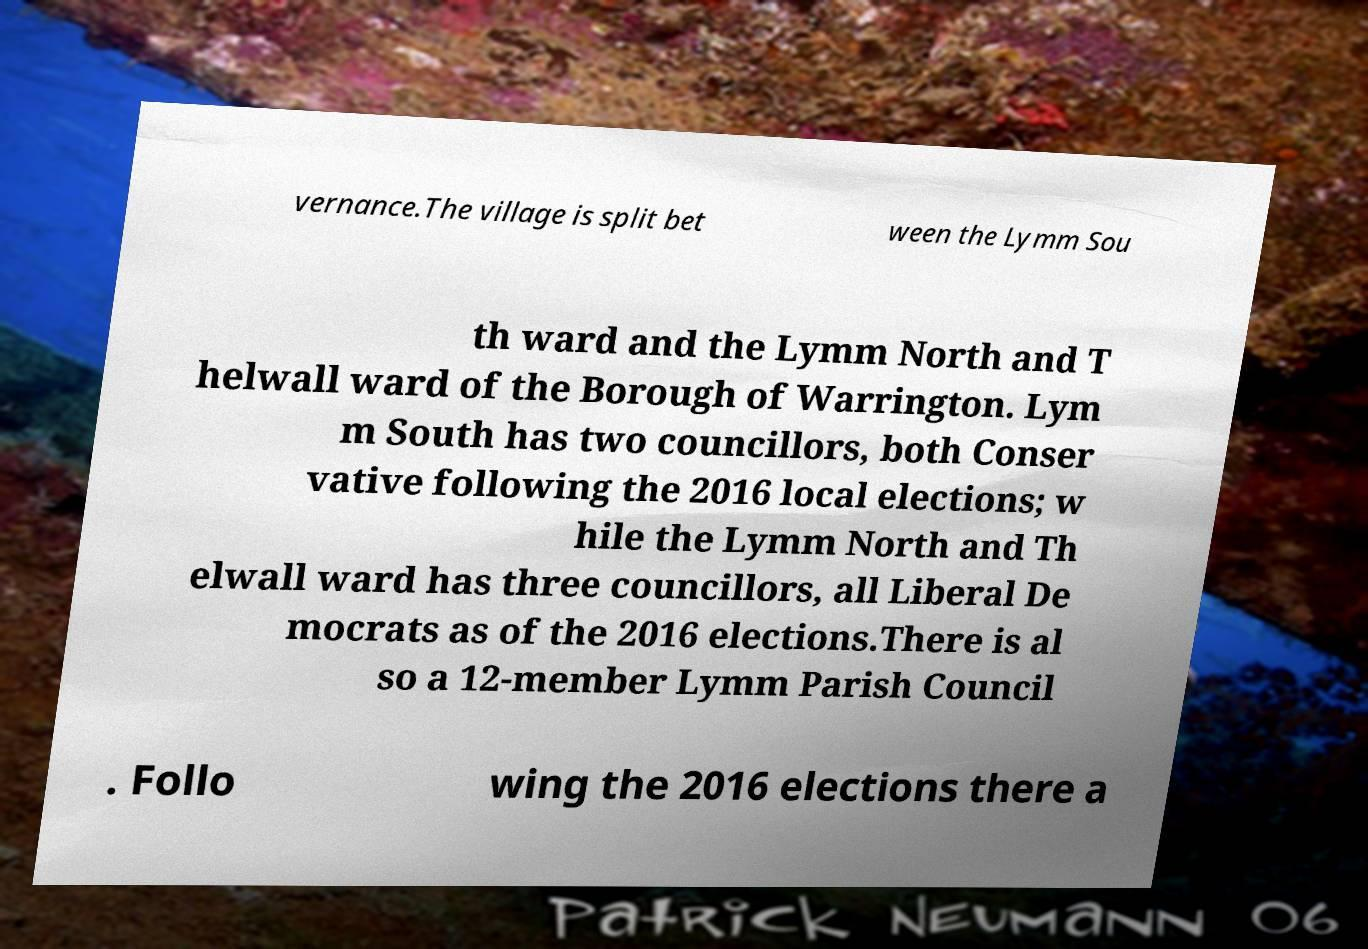Please identify and transcribe the text found in this image. vernance.The village is split bet ween the Lymm Sou th ward and the Lymm North and T helwall ward of the Borough of Warrington. Lym m South has two councillors, both Conser vative following the 2016 local elections; w hile the Lymm North and Th elwall ward has three councillors, all Liberal De mocrats as of the 2016 elections.There is al so a 12-member Lymm Parish Council . Follo wing the 2016 elections there a 